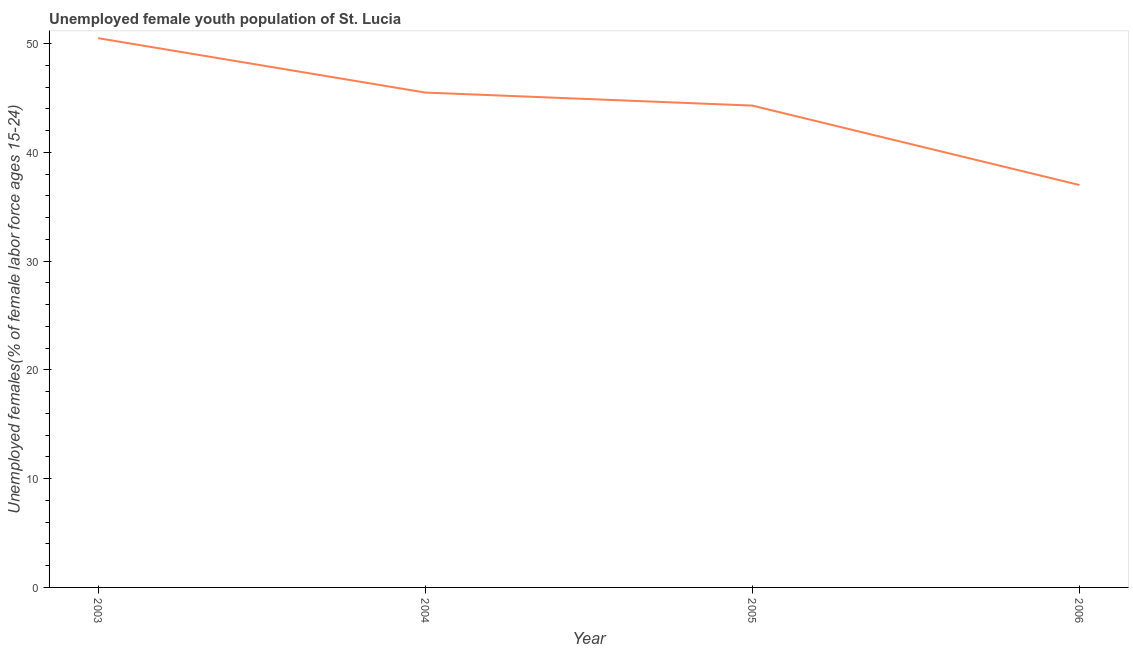What is the unemployed female youth in 2004?
Give a very brief answer. 45.5. Across all years, what is the maximum unemployed female youth?
Provide a short and direct response. 50.5. What is the sum of the unemployed female youth?
Offer a very short reply. 177.3. What is the difference between the unemployed female youth in 2004 and 2006?
Keep it short and to the point. 8.5. What is the average unemployed female youth per year?
Provide a succinct answer. 44.32. What is the median unemployed female youth?
Your answer should be very brief. 44.9. Do a majority of the years between 2004 and 2003 (inclusive) have unemployed female youth greater than 14 %?
Your response must be concise. No. What is the ratio of the unemployed female youth in 2004 to that in 2005?
Offer a very short reply. 1.03. Is the difference between the unemployed female youth in 2003 and 2004 greater than the difference between any two years?
Keep it short and to the point. No. What is the difference between the highest and the second highest unemployed female youth?
Your answer should be compact. 5. Is the sum of the unemployed female youth in 2003 and 2006 greater than the maximum unemployed female youth across all years?
Keep it short and to the point. Yes. Does the unemployed female youth monotonically increase over the years?
Offer a very short reply. No. How many years are there in the graph?
Offer a very short reply. 4. What is the difference between two consecutive major ticks on the Y-axis?
Offer a very short reply. 10. Are the values on the major ticks of Y-axis written in scientific E-notation?
Keep it short and to the point. No. What is the title of the graph?
Provide a short and direct response. Unemployed female youth population of St. Lucia. What is the label or title of the Y-axis?
Provide a short and direct response. Unemployed females(% of female labor force ages 15-24). What is the Unemployed females(% of female labor force ages 15-24) in 2003?
Provide a short and direct response. 50.5. What is the Unemployed females(% of female labor force ages 15-24) in 2004?
Ensure brevity in your answer.  45.5. What is the Unemployed females(% of female labor force ages 15-24) of 2005?
Offer a terse response. 44.3. What is the difference between the Unemployed females(% of female labor force ages 15-24) in 2003 and 2004?
Provide a short and direct response. 5. What is the difference between the Unemployed females(% of female labor force ages 15-24) in 2003 and 2005?
Your answer should be compact. 6.2. What is the difference between the Unemployed females(% of female labor force ages 15-24) in 2003 and 2006?
Ensure brevity in your answer.  13.5. What is the difference between the Unemployed females(% of female labor force ages 15-24) in 2004 and 2005?
Give a very brief answer. 1.2. What is the ratio of the Unemployed females(% of female labor force ages 15-24) in 2003 to that in 2004?
Ensure brevity in your answer.  1.11. What is the ratio of the Unemployed females(% of female labor force ages 15-24) in 2003 to that in 2005?
Offer a very short reply. 1.14. What is the ratio of the Unemployed females(% of female labor force ages 15-24) in 2003 to that in 2006?
Your response must be concise. 1.36. What is the ratio of the Unemployed females(% of female labor force ages 15-24) in 2004 to that in 2005?
Keep it short and to the point. 1.03. What is the ratio of the Unemployed females(% of female labor force ages 15-24) in 2004 to that in 2006?
Provide a short and direct response. 1.23. What is the ratio of the Unemployed females(% of female labor force ages 15-24) in 2005 to that in 2006?
Your answer should be very brief. 1.2. 